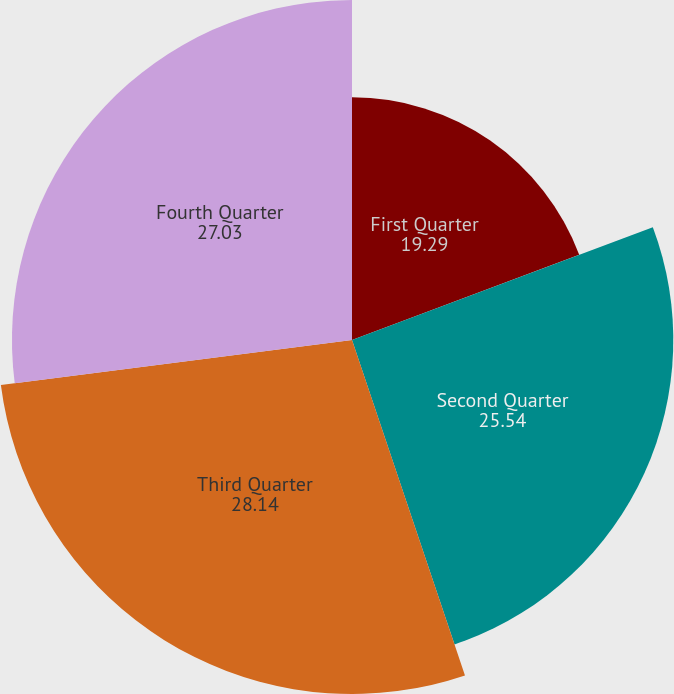Convert chart to OTSL. <chart><loc_0><loc_0><loc_500><loc_500><pie_chart><fcel>First Quarter<fcel>Second Quarter<fcel>Third Quarter<fcel>Fourth Quarter<nl><fcel>19.29%<fcel>25.54%<fcel>28.14%<fcel>27.03%<nl></chart> 